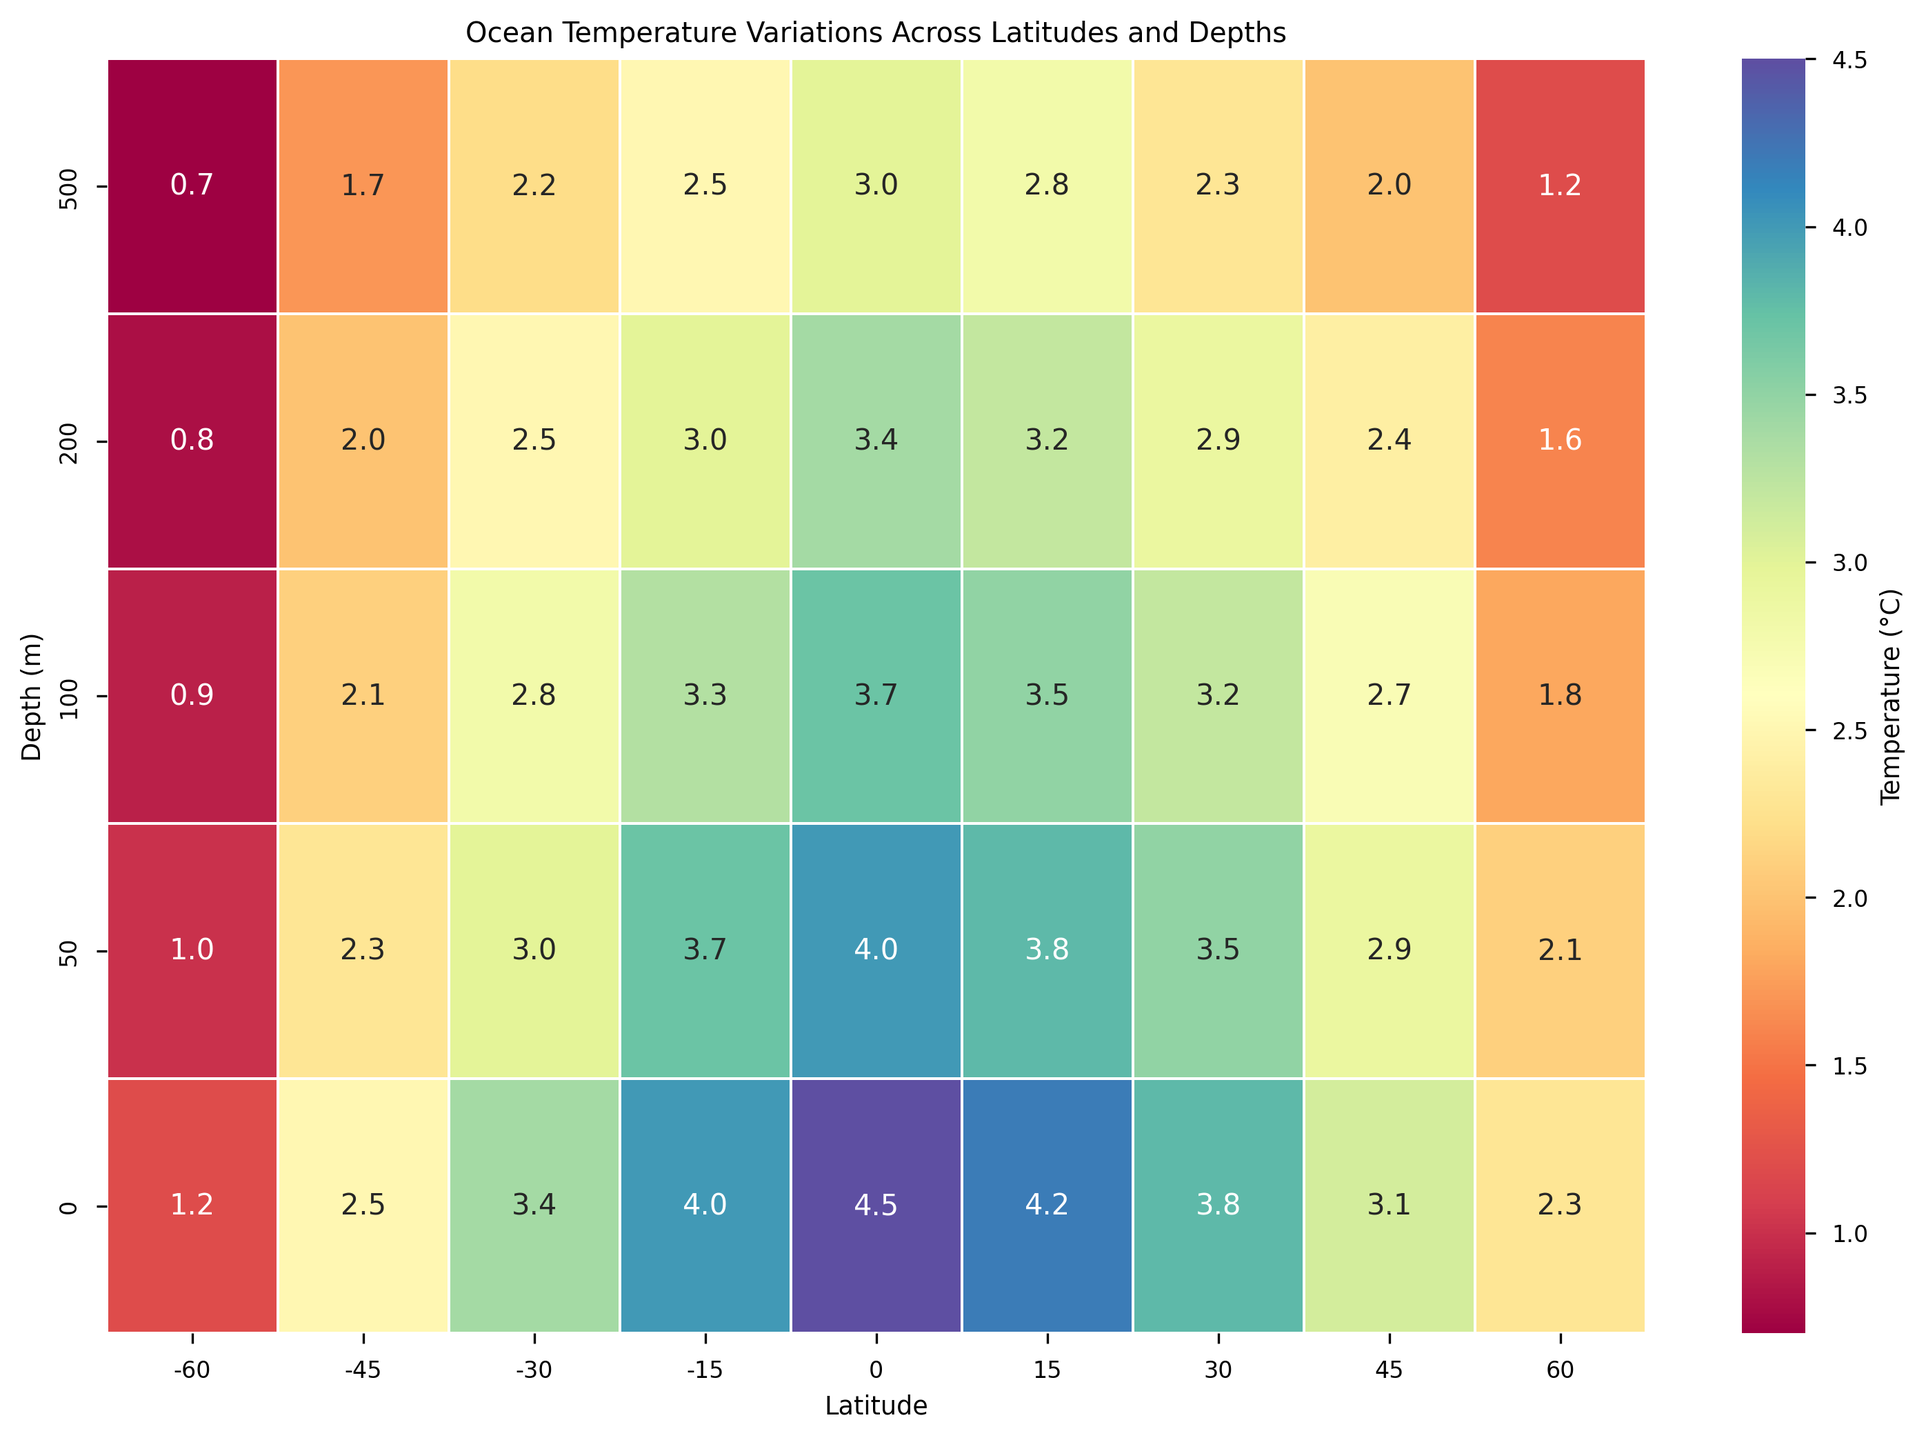What is the temperature at 100 meters depth and -30 latitude? Find the cell corresponding to 100 meters depth and -30 latitude in the heatmap and read the temperature value.
Answer: 2.8 °C Which latitude has the highest surface temperature? Locate the 0 meters depth row and find the highest temperature value among all the latitudes.
Answer: 0 degrees Compare the temperature at 50 meters depth for latitudes -45 and 45. Which one is higher? Locate the temperatures in the 50 meters depth row for -45 and 45 latitudes, and compare the values.
Answer: -45 degrees What is the temperature difference at 200 meters depth between latitudes 0 and 60? Subtract the temperature at 200 meters depth for latitude 60 from the temperature at 200 meters depth for latitude 0. The temperature at 200 meters for 0 and 60 are 3.4 and 1.6 respectively, so the difference is 3.4 - 1.6.
Answer: 1.8 °C Which depth has the most significant temperature drop from latitude -60 to 60? Compare the temperature values from latitude -60 to 60 for each depth and find the depth with the largest difference.
Answer: 0 meters What is the average temperature at 50 meters depth across all latitudes? Sum all the temperature values at 50 meters depth for each latitude and divide by the number of latitudes. Temperatures at 50 meters for each latitude are: 1.0, 2.3, 3.0, 3.7, 4.0, 3.8, 3.5, 2.9, 2.1. Total sum is 26.3 and there are 9 latitudes, so the average is 26.3/9.
Answer: 2.92 °C Is the temperature profile at -30 latitude warmer or cooler compared to 15 latitude? Compare the temperature values at various depths for latitudes -30 and 15. If latitudes at all depths for -30 are warmer, it is considered warmer overall, if cooler, then it's cooler. Summarize -30 values are 3.4, 3.0, 2.8, 2.5, 2.2 and 15 values are 4.2, 3.8, 3.5, 3.2, 2.8.
Answer: Cooler At what depth does the temperature first fall below 2.0°C at 30 latitude? Traverse temperature values for latitude 30 starting from the shallowest (0 meters) to the deepest until finding the first value less than 2.0°C.
Answer: 500 meters Calculate the average difference in temperature between 0 and 500 meters depths for all latitudes. For each latitude, subtract the temperature at 500 meters depth from the temperature at 0 meters depth, then find the average of these differences. Differences per latitude are: 0.5, 0.8, 1.2, 1.5, 1.5, 1.4, 1.5, 1.1, 1.1. Total sum is 10.6, and there are 9 latitudes, so the average difference is 10.6/9.
Answer: 1.18 °C 